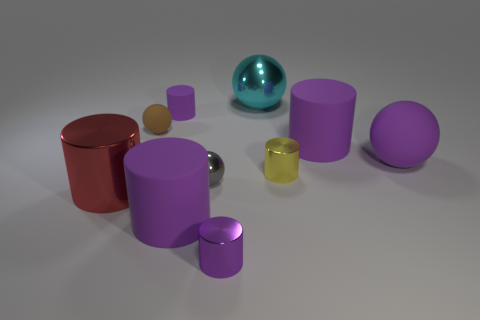What number of tiny rubber cylinders have the same color as the tiny matte sphere?
Provide a succinct answer. 0. There is a brown rubber object that is the same size as the purple metallic cylinder; what is its shape?
Offer a very short reply. Sphere. Are there any purple objects that have the same size as the brown matte object?
Offer a terse response. Yes. There is a brown ball that is the same size as the yellow cylinder; what is its material?
Keep it short and to the point. Rubber. What is the size of the matte cylinder that is behind the brown thing to the left of the cyan metal ball?
Provide a short and direct response. Small. There is a purple matte cylinder right of the gray metallic thing; does it have the same size as the tiny yellow shiny cylinder?
Keep it short and to the point. No. Is the number of small purple matte things in front of the tiny purple rubber cylinder greater than the number of purple things that are right of the small gray metal thing?
Provide a short and direct response. No. What shape is the metal thing that is left of the big cyan metal object and behind the red metal cylinder?
Your answer should be very brief. Sphere. There is a metallic thing on the right side of the large cyan sphere; what is its shape?
Offer a terse response. Cylinder. How big is the purple rubber thing that is behind the big purple matte cylinder that is behind the rubber sphere that is right of the tiny purple matte cylinder?
Your answer should be compact. Small. 